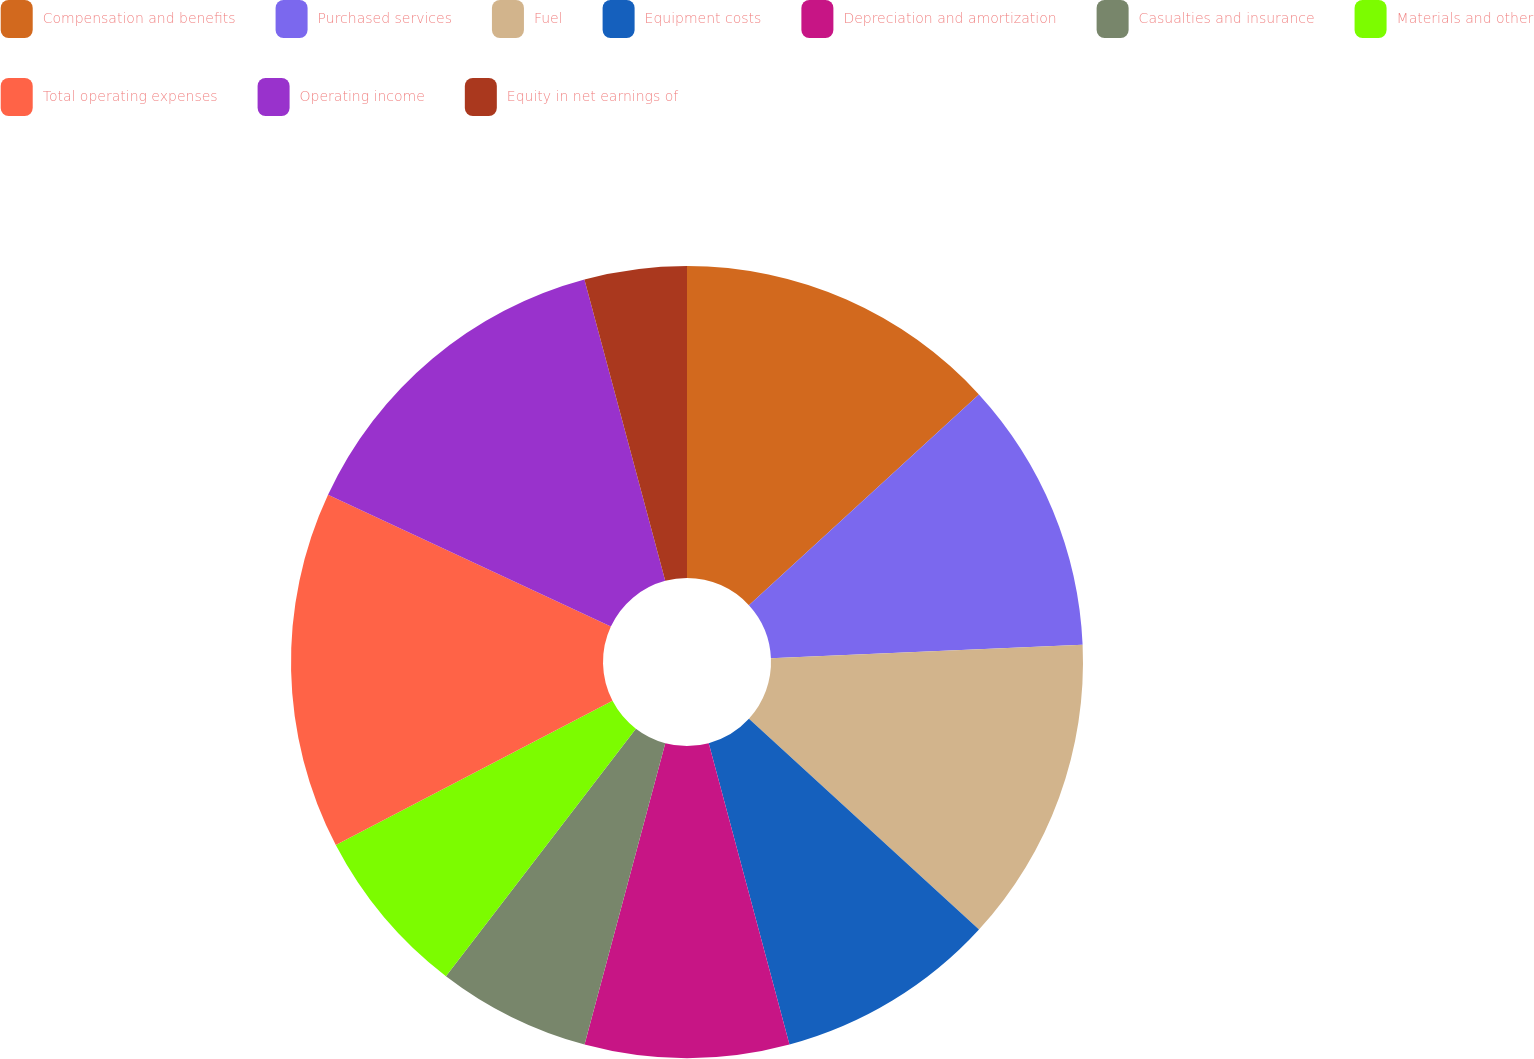<chart> <loc_0><loc_0><loc_500><loc_500><pie_chart><fcel>Compensation and benefits<fcel>Purchased services<fcel>Fuel<fcel>Equipment costs<fcel>Depreciation and amortization<fcel>Casualties and insurance<fcel>Materials and other<fcel>Total operating expenses<fcel>Operating income<fcel>Equity in net earnings of<nl><fcel>13.19%<fcel>11.11%<fcel>12.5%<fcel>9.03%<fcel>8.33%<fcel>6.25%<fcel>6.94%<fcel>14.58%<fcel>13.89%<fcel>4.17%<nl></chart> 